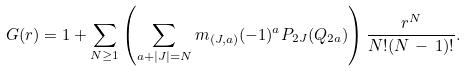<formula> <loc_0><loc_0><loc_500><loc_500>\ G ( r ) = 1 + \sum _ { N \geq 1 } \left ( \sum _ { a + | J | = N } m _ { ( J , a ) } ( - 1 ) ^ { a } P _ { 2 J } ( Q _ { 2 a } ) \right ) \frac { r ^ { N } } { N ! ( N \, - \, 1 ) ! } .</formula> 